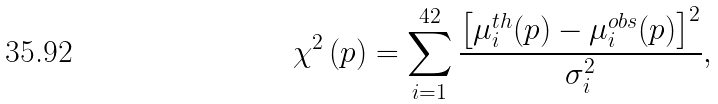<formula> <loc_0><loc_0><loc_500><loc_500>\chi ^ { 2 } \left ( { p } \right ) = \sum _ { i = 1 } ^ { 4 2 } \frac { \left [ \mu ^ { t h } _ { i } ( { p } ) - \mu ^ { o b s } _ { i } ( { p } ) \right ] ^ { 2 } } { \sigma _ { i } ^ { 2 } } ,</formula> 